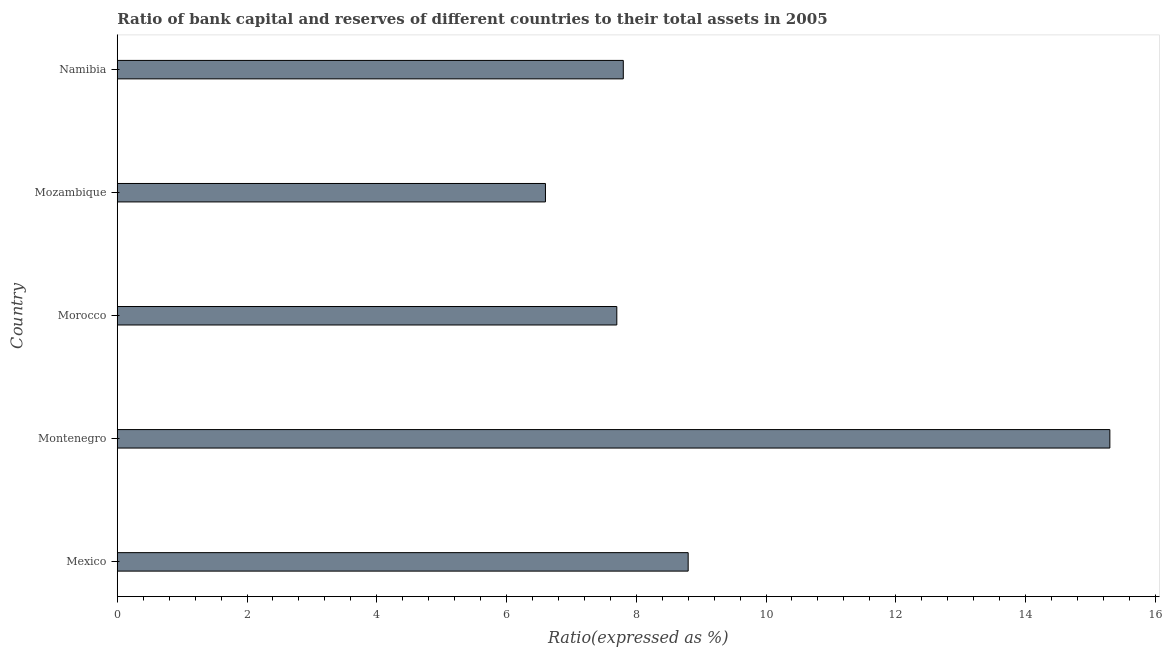What is the title of the graph?
Offer a terse response. Ratio of bank capital and reserves of different countries to their total assets in 2005. What is the label or title of the X-axis?
Offer a very short reply. Ratio(expressed as %). What is the label or title of the Y-axis?
Your answer should be compact. Country. Across all countries, what is the minimum bank capital to assets ratio?
Make the answer very short. 6.6. In which country was the bank capital to assets ratio maximum?
Provide a succinct answer. Montenegro. In which country was the bank capital to assets ratio minimum?
Your response must be concise. Mozambique. What is the sum of the bank capital to assets ratio?
Your response must be concise. 46.2. What is the difference between the bank capital to assets ratio in Morocco and Namibia?
Ensure brevity in your answer.  -0.1. What is the average bank capital to assets ratio per country?
Your answer should be compact. 9.24. What is the median bank capital to assets ratio?
Provide a succinct answer. 7.8. In how many countries, is the bank capital to assets ratio greater than 5.6 %?
Offer a very short reply. 5. Is the bank capital to assets ratio in Mexico less than that in Mozambique?
Your answer should be compact. No. Is the sum of the bank capital to assets ratio in Montenegro and Namibia greater than the maximum bank capital to assets ratio across all countries?
Offer a very short reply. Yes. What is the difference between the highest and the lowest bank capital to assets ratio?
Provide a succinct answer. 8.7. How many bars are there?
Keep it short and to the point. 5. Are all the bars in the graph horizontal?
Keep it short and to the point. Yes. How many countries are there in the graph?
Give a very brief answer. 5. Are the values on the major ticks of X-axis written in scientific E-notation?
Keep it short and to the point. No. What is the Ratio(expressed as %) in Mexico?
Offer a very short reply. 8.8. What is the Ratio(expressed as %) in Montenegro?
Your answer should be compact. 15.3. What is the Ratio(expressed as %) of Morocco?
Make the answer very short. 7.7. What is the Ratio(expressed as %) in Mozambique?
Your answer should be very brief. 6.6. What is the Ratio(expressed as %) of Namibia?
Your answer should be very brief. 7.8. What is the difference between the Ratio(expressed as %) in Mexico and Morocco?
Keep it short and to the point. 1.1. What is the difference between the Ratio(expressed as %) in Mexico and Mozambique?
Ensure brevity in your answer.  2.2. What is the difference between the Ratio(expressed as %) in Montenegro and Namibia?
Your response must be concise. 7.5. What is the difference between the Ratio(expressed as %) in Morocco and Mozambique?
Provide a short and direct response. 1.1. What is the difference between the Ratio(expressed as %) in Morocco and Namibia?
Offer a very short reply. -0.1. What is the difference between the Ratio(expressed as %) in Mozambique and Namibia?
Make the answer very short. -1.2. What is the ratio of the Ratio(expressed as %) in Mexico to that in Montenegro?
Make the answer very short. 0.57. What is the ratio of the Ratio(expressed as %) in Mexico to that in Morocco?
Offer a terse response. 1.14. What is the ratio of the Ratio(expressed as %) in Mexico to that in Mozambique?
Make the answer very short. 1.33. What is the ratio of the Ratio(expressed as %) in Mexico to that in Namibia?
Make the answer very short. 1.13. What is the ratio of the Ratio(expressed as %) in Montenegro to that in Morocco?
Provide a succinct answer. 1.99. What is the ratio of the Ratio(expressed as %) in Montenegro to that in Mozambique?
Your response must be concise. 2.32. What is the ratio of the Ratio(expressed as %) in Montenegro to that in Namibia?
Your response must be concise. 1.96. What is the ratio of the Ratio(expressed as %) in Morocco to that in Mozambique?
Offer a terse response. 1.17. What is the ratio of the Ratio(expressed as %) in Mozambique to that in Namibia?
Your answer should be compact. 0.85. 